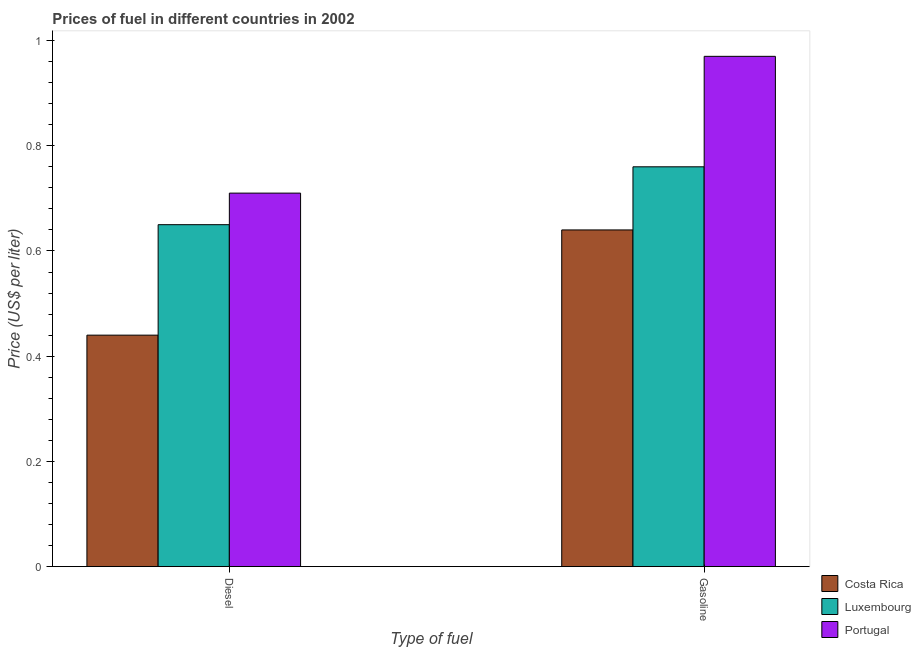Are the number of bars per tick equal to the number of legend labels?
Ensure brevity in your answer.  Yes. Are the number of bars on each tick of the X-axis equal?
Offer a terse response. Yes. What is the label of the 1st group of bars from the left?
Keep it short and to the point. Diesel. What is the diesel price in Costa Rica?
Provide a succinct answer. 0.44. Across all countries, what is the maximum gasoline price?
Your answer should be compact. 0.97. Across all countries, what is the minimum diesel price?
Provide a succinct answer. 0.44. What is the total gasoline price in the graph?
Your answer should be compact. 2.37. What is the difference between the gasoline price in Portugal and that in Costa Rica?
Keep it short and to the point. 0.33. What is the difference between the diesel price in Portugal and the gasoline price in Luxembourg?
Provide a succinct answer. -0.05. What is the average gasoline price per country?
Provide a succinct answer. 0.79. What is the ratio of the diesel price in Portugal to that in Luxembourg?
Offer a very short reply. 1.09. What does the 2nd bar from the left in Gasoline represents?
Offer a very short reply. Luxembourg. What does the 2nd bar from the right in Diesel represents?
Offer a very short reply. Luxembourg. Are all the bars in the graph horizontal?
Offer a very short reply. No. Are the values on the major ticks of Y-axis written in scientific E-notation?
Provide a short and direct response. No. Does the graph contain any zero values?
Provide a short and direct response. No. Does the graph contain grids?
Give a very brief answer. No. What is the title of the graph?
Make the answer very short. Prices of fuel in different countries in 2002. Does "South Africa" appear as one of the legend labels in the graph?
Offer a terse response. No. What is the label or title of the X-axis?
Provide a short and direct response. Type of fuel. What is the label or title of the Y-axis?
Your response must be concise. Price (US$ per liter). What is the Price (US$ per liter) of Costa Rica in Diesel?
Your answer should be very brief. 0.44. What is the Price (US$ per liter) in Luxembourg in Diesel?
Offer a terse response. 0.65. What is the Price (US$ per liter) in Portugal in Diesel?
Offer a terse response. 0.71. What is the Price (US$ per liter) in Costa Rica in Gasoline?
Your response must be concise. 0.64. What is the Price (US$ per liter) in Luxembourg in Gasoline?
Offer a very short reply. 0.76. What is the Price (US$ per liter) in Portugal in Gasoline?
Offer a very short reply. 0.97. Across all Type of fuel, what is the maximum Price (US$ per liter) of Costa Rica?
Make the answer very short. 0.64. Across all Type of fuel, what is the maximum Price (US$ per liter) of Luxembourg?
Keep it short and to the point. 0.76. Across all Type of fuel, what is the maximum Price (US$ per liter) in Portugal?
Your response must be concise. 0.97. Across all Type of fuel, what is the minimum Price (US$ per liter) of Costa Rica?
Give a very brief answer. 0.44. Across all Type of fuel, what is the minimum Price (US$ per liter) of Luxembourg?
Offer a very short reply. 0.65. Across all Type of fuel, what is the minimum Price (US$ per liter) of Portugal?
Offer a very short reply. 0.71. What is the total Price (US$ per liter) in Luxembourg in the graph?
Your response must be concise. 1.41. What is the total Price (US$ per liter) in Portugal in the graph?
Keep it short and to the point. 1.68. What is the difference between the Price (US$ per liter) of Luxembourg in Diesel and that in Gasoline?
Provide a short and direct response. -0.11. What is the difference between the Price (US$ per liter) in Portugal in Diesel and that in Gasoline?
Ensure brevity in your answer.  -0.26. What is the difference between the Price (US$ per liter) in Costa Rica in Diesel and the Price (US$ per liter) in Luxembourg in Gasoline?
Make the answer very short. -0.32. What is the difference between the Price (US$ per liter) in Costa Rica in Diesel and the Price (US$ per liter) in Portugal in Gasoline?
Your response must be concise. -0.53. What is the difference between the Price (US$ per liter) of Luxembourg in Diesel and the Price (US$ per liter) of Portugal in Gasoline?
Offer a very short reply. -0.32. What is the average Price (US$ per liter) in Costa Rica per Type of fuel?
Your answer should be compact. 0.54. What is the average Price (US$ per liter) of Luxembourg per Type of fuel?
Your answer should be very brief. 0.7. What is the average Price (US$ per liter) of Portugal per Type of fuel?
Keep it short and to the point. 0.84. What is the difference between the Price (US$ per liter) in Costa Rica and Price (US$ per liter) in Luxembourg in Diesel?
Give a very brief answer. -0.21. What is the difference between the Price (US$ per liter) of Costa Rica and Price (US$ per liter) of Portugal in Diesel?
Your response must be concise. -0.27. What is the difference between the Price (US$ per liter) of Luxembourg and Price (US$ per liter) of Portugal in Diesel?
Your answer should be compact. -0.06. What is the difference between the Price (US$ per liter) of Costa Rica and Price (US$ per liter) of Luxembourg in Gasoline?
Give a very brief answer. -0.12. What is the difference between the Price (US$ per liter) of Costa Rica and Price (US$ per liter) of Portugal in Gasoline?
Your response must be concise. -0.33. What is the difference between the Price (US$ per liter) in Luxembourg and Price (US$ per liter) in Portugal in Gasoline?
Offer a terse response. -0.21. What is the ratio of the Price (US$ per liter) of Costa Rica in Diesel to that in Gasoline?
Make the answer very short. 0.69. What is the ratio of the Price (US$ per liter) in Luxembourg in Diesel to that in Gasoline?
Offer a terse response. 0.86. What is the ratio of the Price (US$ per liter) of Portugal in Diesel to that in Gasoline?
Your answer should be compact. 0.73. What is the difference between the highest and the second highest Price (US$ per liter) of Costa Rica?
Make the answer very short. 0.2. What is the difference between the highest and the second highest Price (US$ per liter) of Luxembourg?
Offer a terse response. 0.11. What is the difference between the highest and the second highest Price (US$ per liter) in Portugal?
Offer a very short reply. 0.26. What is the difference between the highest and the lowest Price (US$ per liter) of Luxembourg?
Your answer should be very brief. 0.11. What is the difference between the highest and the lowest Price (US$ per liter) in Portugal?
Give a very brief answer. 0.26. 